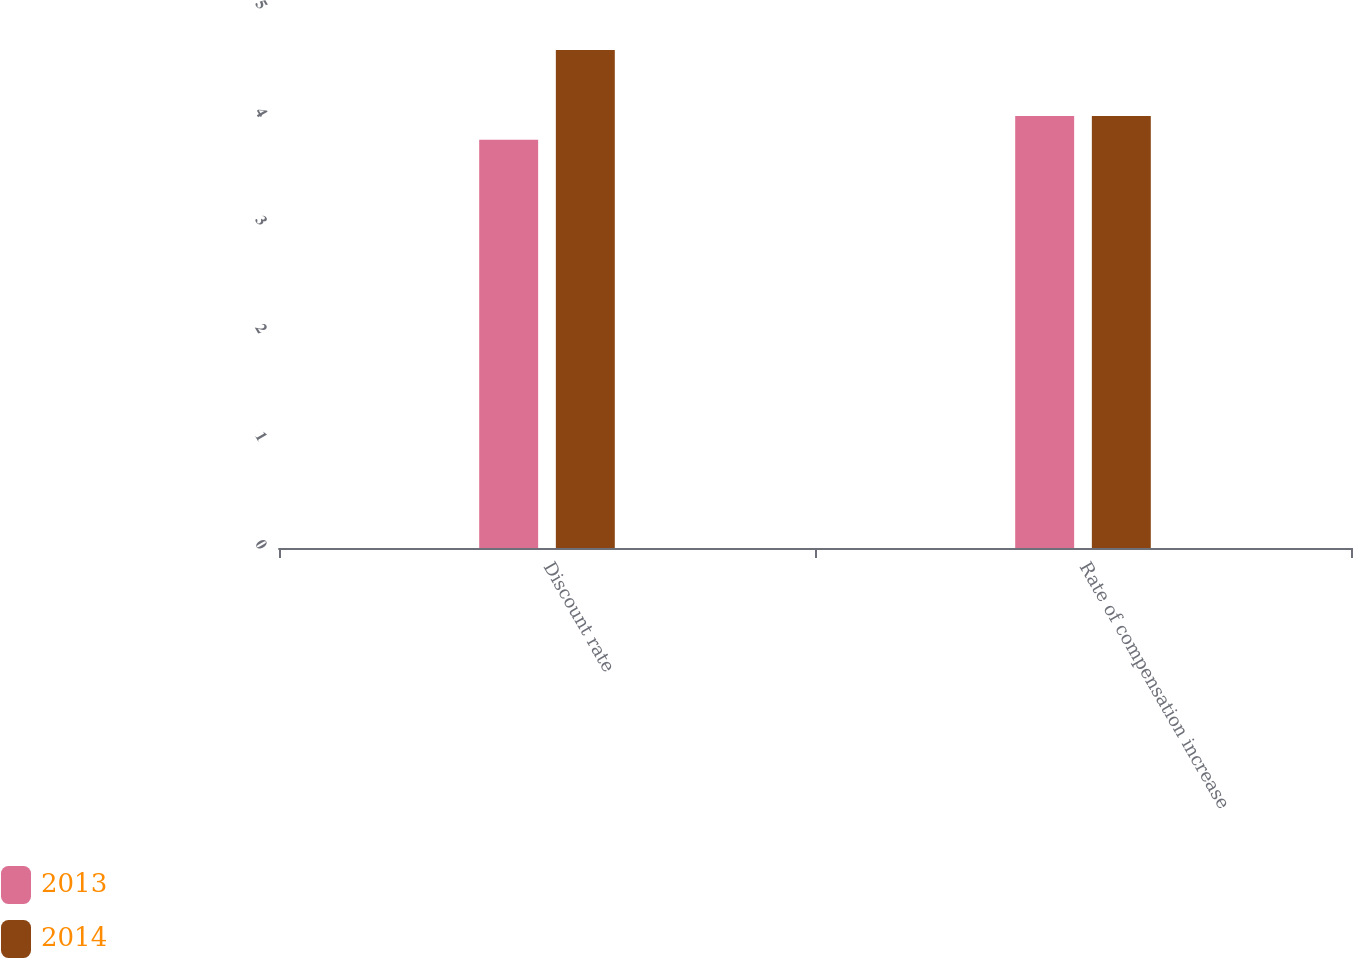<chart> <loc_0><loc_0><loc_500><loc_500><stacked_bar_chart><ecel><fcel>Discount rate<fcel>Rate of compensation increase<nl><fcel>2013<fcel>3.78<fcel>4<nl><fcel>2014<fcel>4.61<fcel>4<nl></chart> 